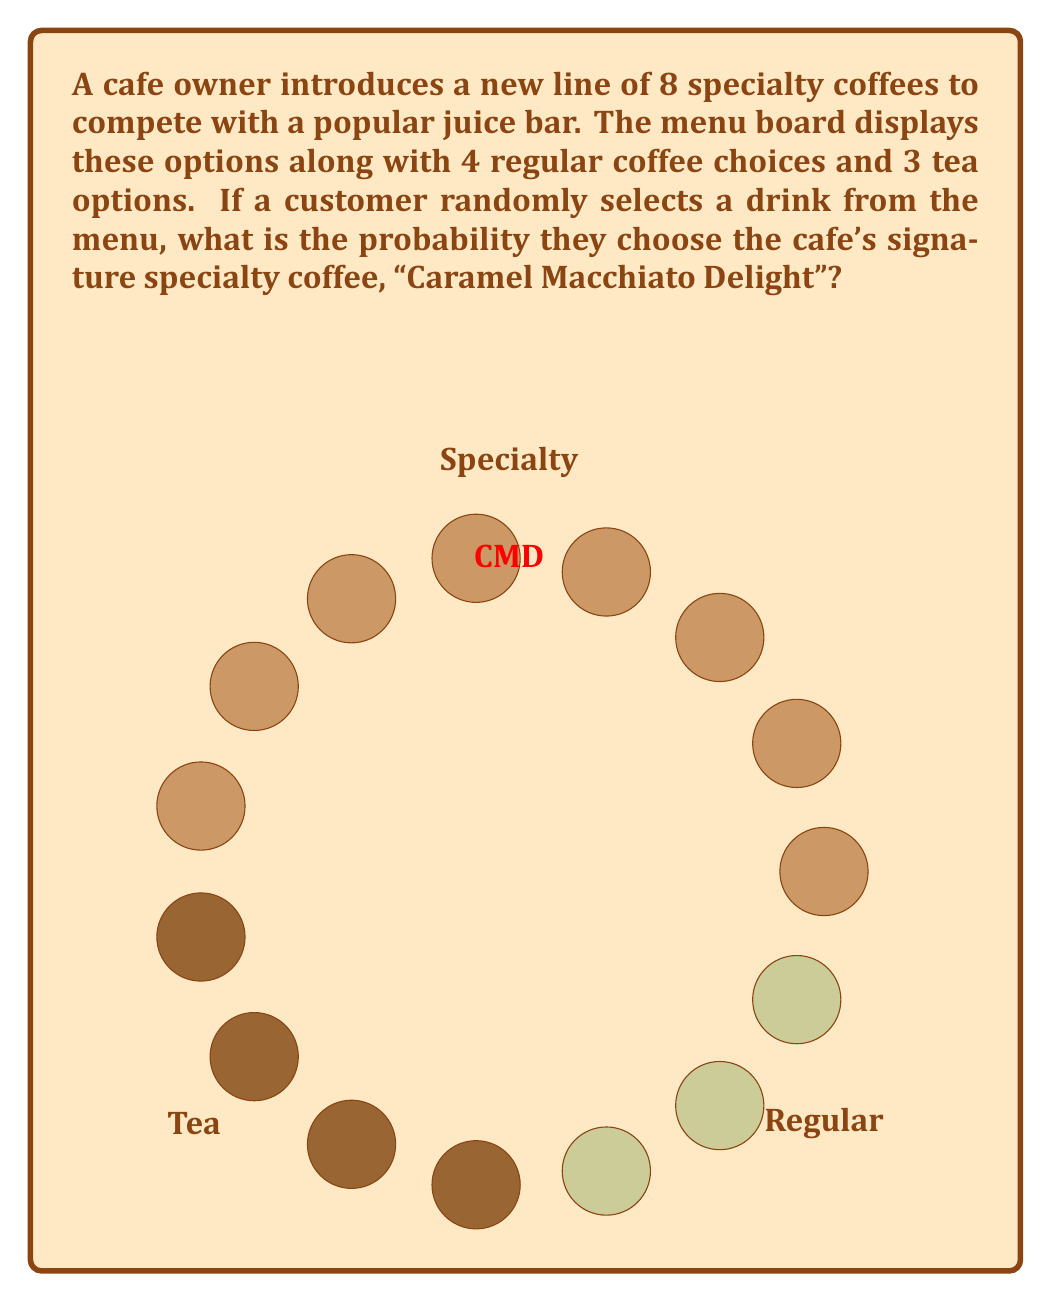Teach me how to tackle this problem. To solve this problem, we need to use the concept of probability in a finite sample space. Let's break it down step by step:

1) First, let's identify the total number of options on the menu:
   - 8 specialty coffees
   - 4 regular coffee choices
   - 3 tea options
   
   Total options = $8 + 4 + 3 = 15$

2) The probability of an event occurring is calculated by:

   $$ P(\text{event}) = \frac{\text{number of favorable outcomes}}{\text{total number of possible outcomes}} $$

3) In this case:
   - The favorable outcome is choosing the "Caramel Macchiato Delight"
   - There is only 1 "Caramel Macchiato Delight" in the menu
   - The total number of possible outcomes is 15 (all drink options)

4) Therefore, the probability of choosing the "Caramel Macchiato Delight" is:

   $$ P(\text{Caramel Macchiato Delight}) = \frac{1}{15} $$

5) This can be simplified to:

   $$ P(\text{Caramel Macchiato Delight}) = \frac{1}{15} = 0.0666... $$

Thus, there is approximately a 6.67% chance that a customer will randomly choose the "Caramel Macchiato Delight" from the menu.
Answer: $\frac{1}{15}$ 